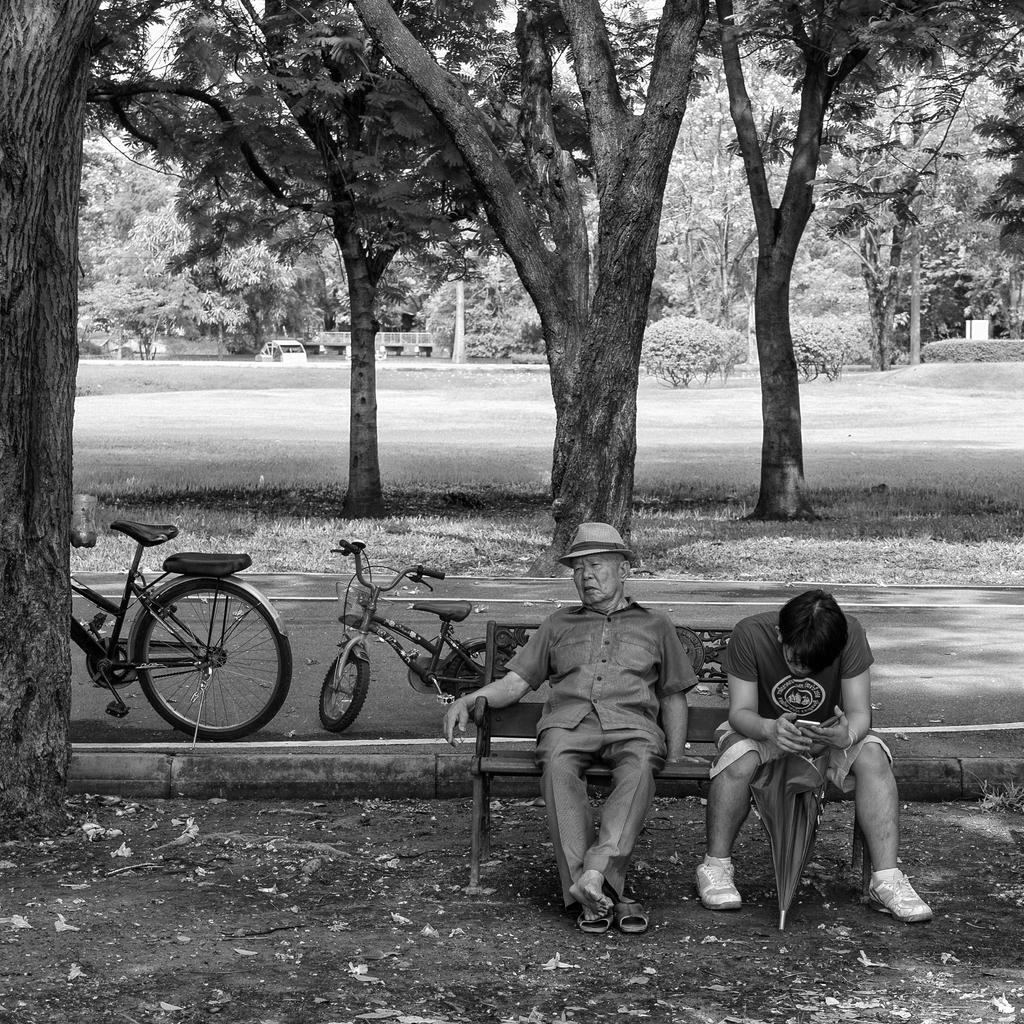What are the two people in the image doing? The two people are sitting on a bench in the center of the image. What can be seen on the left side of the image? There are bicycles on the road on the left side of the image. What type of vegetation is visible in the background of the image? There are trees and bushes in the background of the image. What type of vehicle is visible in the background of the image? There is a car in the background of the image. What type of mitten is the representative wearing in the image? There is no representative or mitten present in the image. 